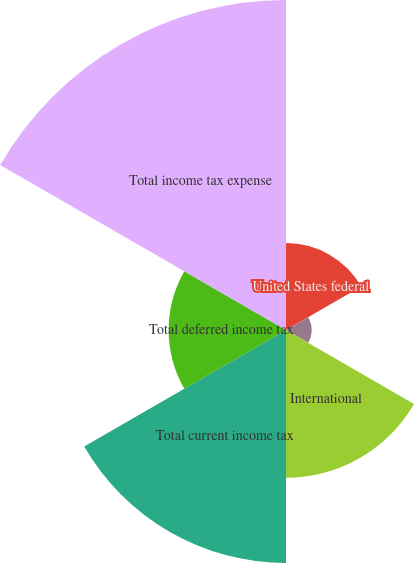Convert chart to OTSL. <chart><loc_0><loc_0><loc_500><loc_500><pie_chart><fcel>United States federal<fcel>United States state and local<fcel>International<fcel>Total current income tax<fcel>Total deferred income tax<fcel>Total income tax expense<nl><fcel>9.24%<fcel>2.73%<fcel>15.71%<fcel>24.77%<fcel>12.48%<fcel>35.08%<nl></chart> 